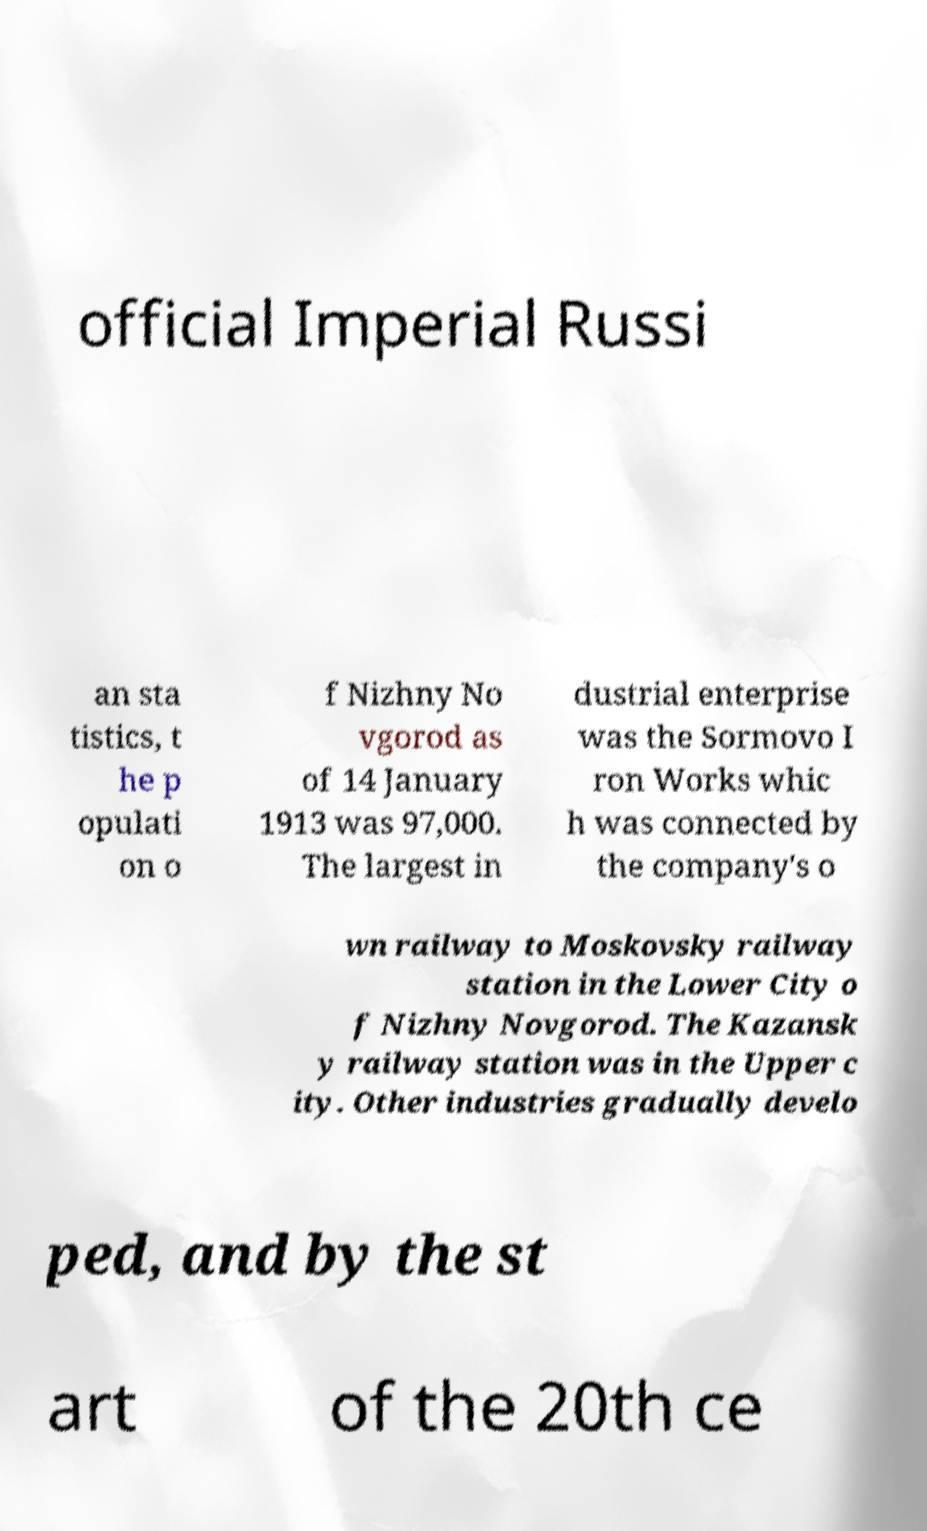What messages or text are displayed in this image? I need them in a readable, typed format. official Imperial Russi an sta tistics, t he p opulati on o f Nizhny No vgorod as of 14 January 1913 was 97,000. The largest in dustrial enterprise was the Sormovo I ron Works whic h was connected by the company's o wn railway to Moskovsky railway station in the Lower City o f Nizhny Novgorod. The Kazansk y railway station was in the Upper c ity. Other industries gradually develo ped, and by the st art of the 20th ce 